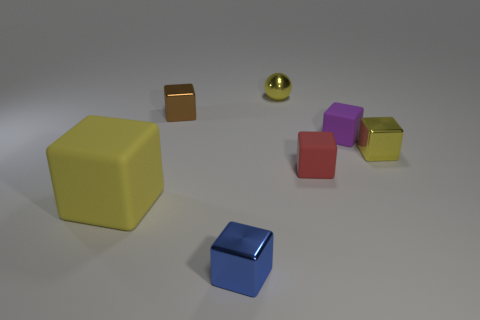Subtract 3 cubes. How many cubes are left? 3 Subtract all small yellow metallic cubes. How many cubes are left? 5 Subtract all purple blocks. How many blocks are left? 5 Subtract all purple cubes. Subtract all brown balls. How many cubes are left? 5 Add 1 small purple objects. How many objects exist? 8 Subtract all spheres. How many objects are left? 6 Subtract all purple rubber things. Subtract all tiny brown metallic cubes. How many objects are left? 5 Add 3 tiny brown cubes. How many tiny brown cubes are left? 4 Add 5 gray cylinders. How many gray cylinders exist? 5 Subtract 0 cyan cylinders. How many objects are left? 7 